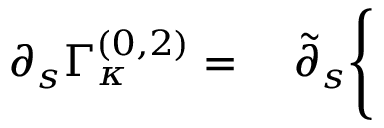<formula> <loc_0><loc_0><loc_500><loc_500>\partial _ { s } \Gamma _ { \kappa } ^ { ( 0 , 2 ) } = \quad \tilde { \partial } _ { s } \Big \{</formula> 